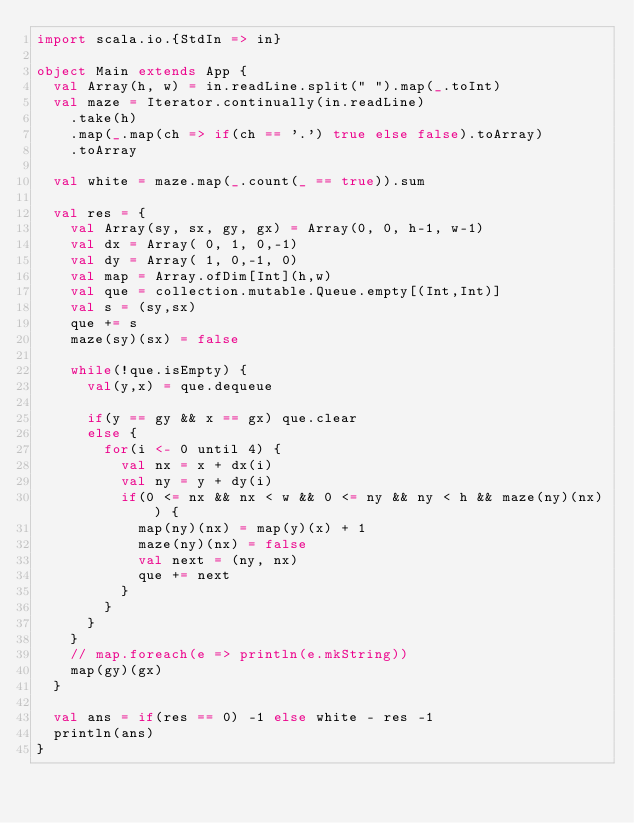Convert code to text. <code><loc_0><loc_0><loc_500><loc_500><_Scala_>import scala.io.{StdIn => in}

object Main extends App {
  val Array(h, w) = in.readLine.split(" ").map(_.toInt)
  val maze = Iterator.continually(in.readLine)
    .take(h)
    .map(_.map(ch => if(ch == '.') true else false).toArray)
    .toArray

  val white = maze.map(_.count(_ == true)).sum
  
  val res = {
    val Array(sy, sx, gy, gx) = Array(0, 0, h-1, w-1)
    val dx = Array( 0, 1, 0,-1)
    val dy = Array( 1, 0,-1, 0)
    val map = Array.ofDim[Int](h,w)
    val que = collection.mutable.Queue.empty[(Int,Int)]
    val s = (sy,sx)
    que += s
    maze(sy)(sx) = false

    while(!que.isEmpty) {
      val(y,x) = que.dequeue

      if(y == gy && x == gx) que.clear
      else {
        for(i <- 0 until 4) {
          val nx = x + dx(i)
          val ny = y + dy(i)
          if(0 <= nx && nx < w && 0 <= ny && ny < h && maze(ny)(nx)) {
            map(ny)(nx) = map(y)(x) + 1
            maze(ny)(nx) = false
            val next = (ny, nx)
            que += next
          }
        }
      }
    }
    // map.foreach(e => println(e.mkString))
    map(gy)(gx)
  }

  val ans = if(res == 0) -1 else white - res -1
  println(ans)
}</code> 